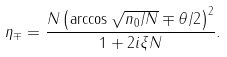Convert formula to latex. <formula><loc_0><loc_0><loc_500><loc_500>\eta _ { \mp } = \frac { N \left ( \arccos \sqrt { n _ { 0 } / N } \mp \theta / 2 \right ) ^ { 2 } } { 1 + 2 i \xi N } .</formula> 